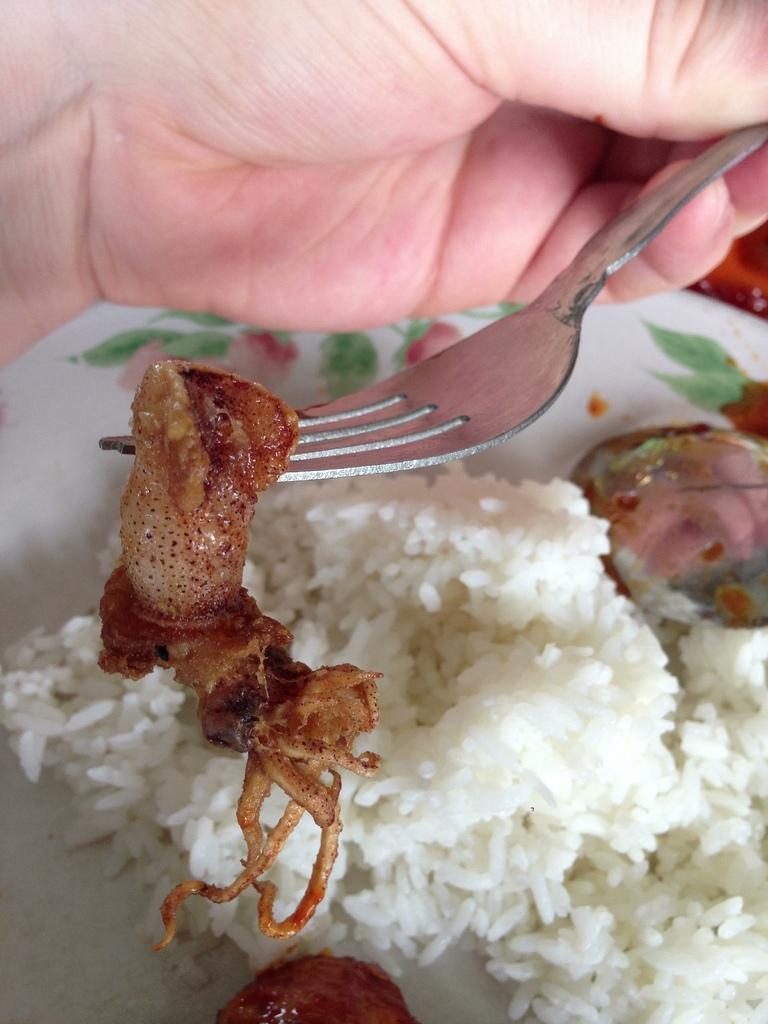In one or two sentences, can you explain what this image depicts? In this image I can see a hand of a person is holding a fork. I can also see a white colour plate, a brown colour food and white colour rice. 